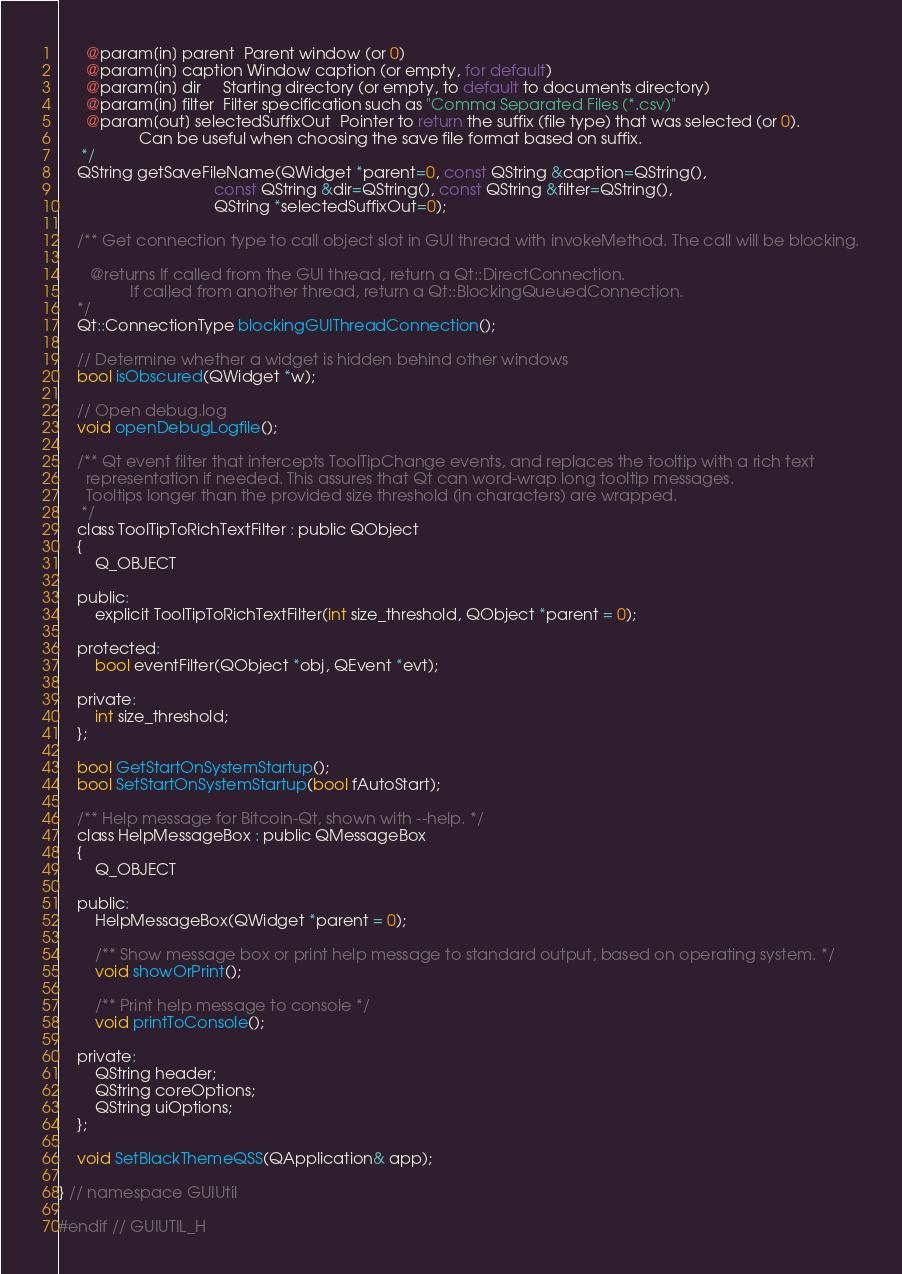Convert code to text. <code><loc_0><loc_0><loc_500><loc_500><_C_>      @param[in] parent  Parent window (or 0)
      @param[in] caption Window caption (or empty, for default)
      @param[in] dir     Starting directory (or empty, to default to documents directory)
      @param[in] filter  Filter specification such as "Comma Separated Files (*.csv)"
      @param[out] selectedSuffixOut  Pointer to return the suffix (file type) that was selected (or 0).
                  Can be useful when choosing the save file format based on suffix.
     */
    QString getSaveFileName(QWidget *parent=0, const QString &caption=QString(),
                                   const QString &dir=QString(), const QString &filter=QString(),
                                   QString *selectedSuffixOut=0);

    /** Get connection type to call object slot in GUI thread with invokeMethod. The call will be blocking.

       @returns If called from the GUI thread, return a Qt::DirectConnection.
                If called from another thread, return a Qt::BlockingQueuedConnection.
    */
    Qt::ConnectionType blockingGUIThreadConnection();

    // Determine whether a widget is hidden behind other windows
    bool isObscured(QWidget *w);

    // Open debug.log
    void openDebugLogfile();

    /** Qt event filter that intercepts ToolTipChange events, and replaces the tooltip with a rich text
      representation if needed. This assures that Qt can word-wrap long tooltip messages.
      Tooltips longer than the provided size threshold (in characters) are wrapped.
     */
    class ToolTipToRichTextFilter : public QObject
    {
        Q_OBJECT

    public:
        explicit ToolTipToRichTextFilter(int size_threshold, QObject *parent = 0);

    protected:
        bool eventFilter(QObject *obj, QEvent *evt);

    private:
        int size_threshold;
    };

    bool GetStartOnSystemStartup();
    bool SetStartOnSystemStartup(bool fAutoStart);

    /** Help message for Bitcoin-Qt, shown with --help. */
    class HelpMessageBox : public QMessageBox
    {
        Q_OBJECT

    public:
        HelpMessageBox(QWidget *parent = 0);

        /** Show message box or print help message to standard output, based on operating system. */
        void showOrPrint();

        /** Print help message to console */
        void printToConsole();

    private:
        QString header;
        QString coreOptions;
        QString uiOptions;
    };

    void SetBlackThemeQSS(QApplication& app);

} // namespace GUIUtil

#endif // GUIUTIL_H
</code> 